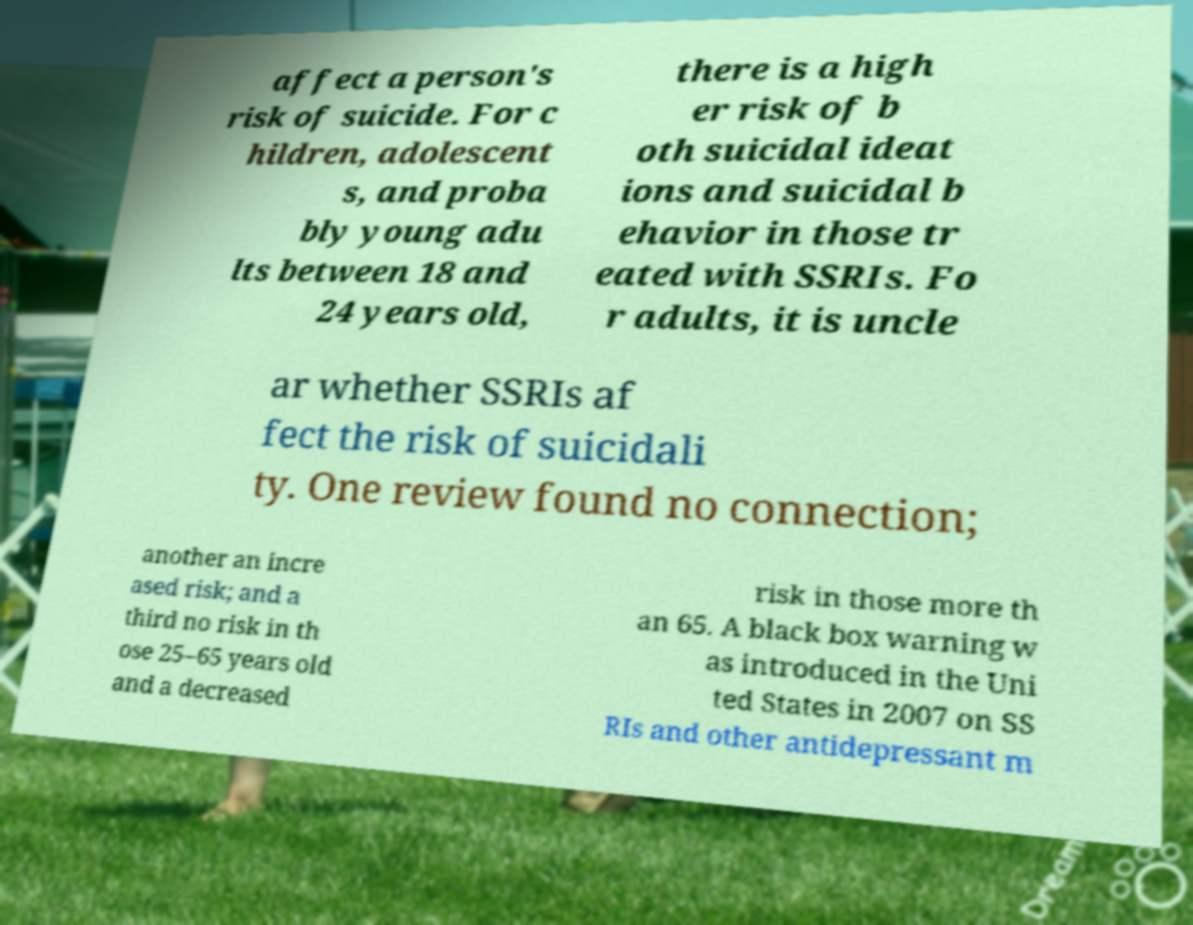I need the written content from this picture converted into text. Can you do that? affect a person's risk of suicide. For c hildren, adolescent s, and proba bly young adu lts between 18 and 24 years old, there is a high er risk of b oth suicidal ideat ions and suicidal b ehavior in those tr eated with SSRIs. Fo r adults, it is uncle ar whether SSRIs af fect the risk of suicidali ty. One review found no connection; another an incre ased risk; and a third no risk in th ose 25–65 years old and a decreased risk in those more th an 65. A black box warning w as introduced in the Uni ted States in 2007 on SS RIs and other antidepressant m 